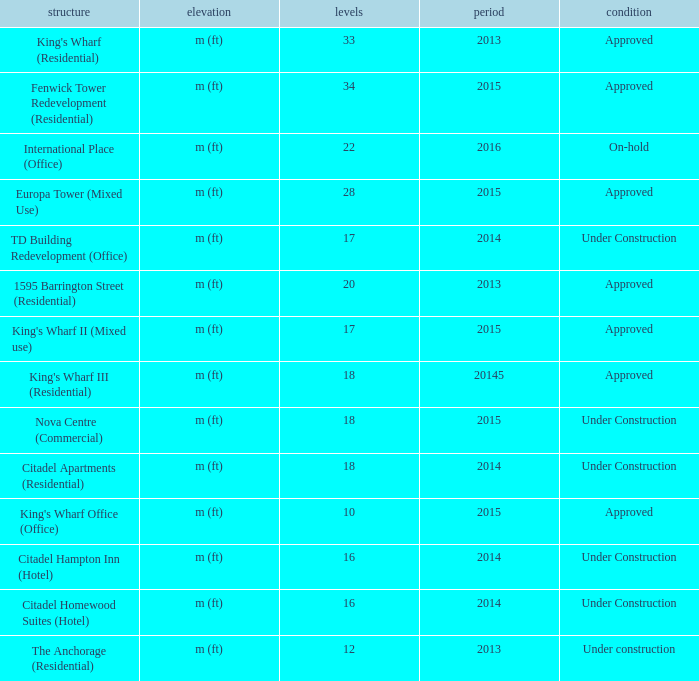What is the condition of the structure with fewer than 18 stories and built after 2013? Under Construction, Approved, Approved, Under Construction, Under Construction. 